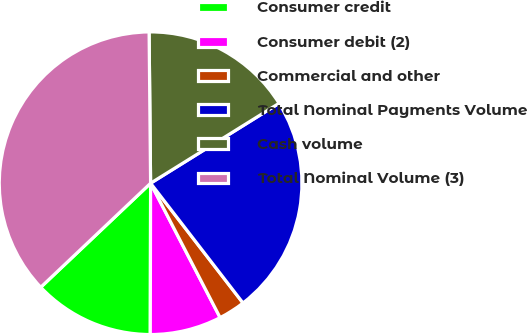Convert chart. <chart><loc_0><loc_0><loc_500><loc_500><pie_chart><fcel>Consumer credit<fcel>Consumer debit (2)<fcel>Commercial and other<fcel>Total Nominal Payments Volume<fcel>Cash volume<fcel>Total Nominal Volume (3)<nl><fcel>12.9%<fcel>7.63%<fcel>2.86%<fcel>23.4%<fcel>16.3%<fcel>36.91%<nl></chart> 